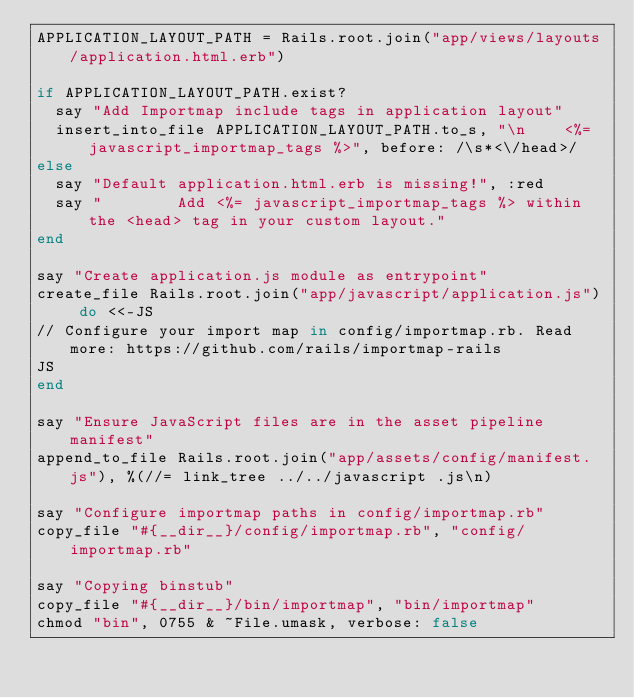Convert code to text. <code><loc_0><loc_0><loc_500><loc_500><_Ruby_>APPLICATION_LAYOUT_PATH = Rails.root.join("app/views/layouts/application.html.erb")

if APPLICATION_LAYOUT_PATH.exist?
  say "Add Importmap include tags in application layout"
  insert_into_file APPLICATION_LAYOUT_PATH.to_s, "\n    <%= javascript_importmap_tags %>", before: /\s*<\/head>/
else
  say "Default application.html.erb is missing!", :red
  say "        Add <%= javascript_importmap_tags %> within the <head> tag in your custom layout."
end

say "Create application.js module as entrypoint"
create_file Rails.root.join("app/javascript/application.js") do <<-JS
// Configure your import map in config/importmap.rb. Read more: https://github.com/rails/importmap-rails
JS
end

say "Ensure JavaScript files are in the asset pipeline manifest"
append_to_file Rails.root.join("app/assets/config/manifest.js"), %(//= link_tree ../../javascript .js\n)

say "Configure importmap paths in config/importmap.rb"
copy_file "#{__dir__}/config/importmap.rb", "config/importmap.rb"

say "Copying binstub"
copy_file "#{__dir__}/bin/importmap", "bin/importmap"
chmod "bin", 0755 & ~File.umask, verbose: false
</code> 